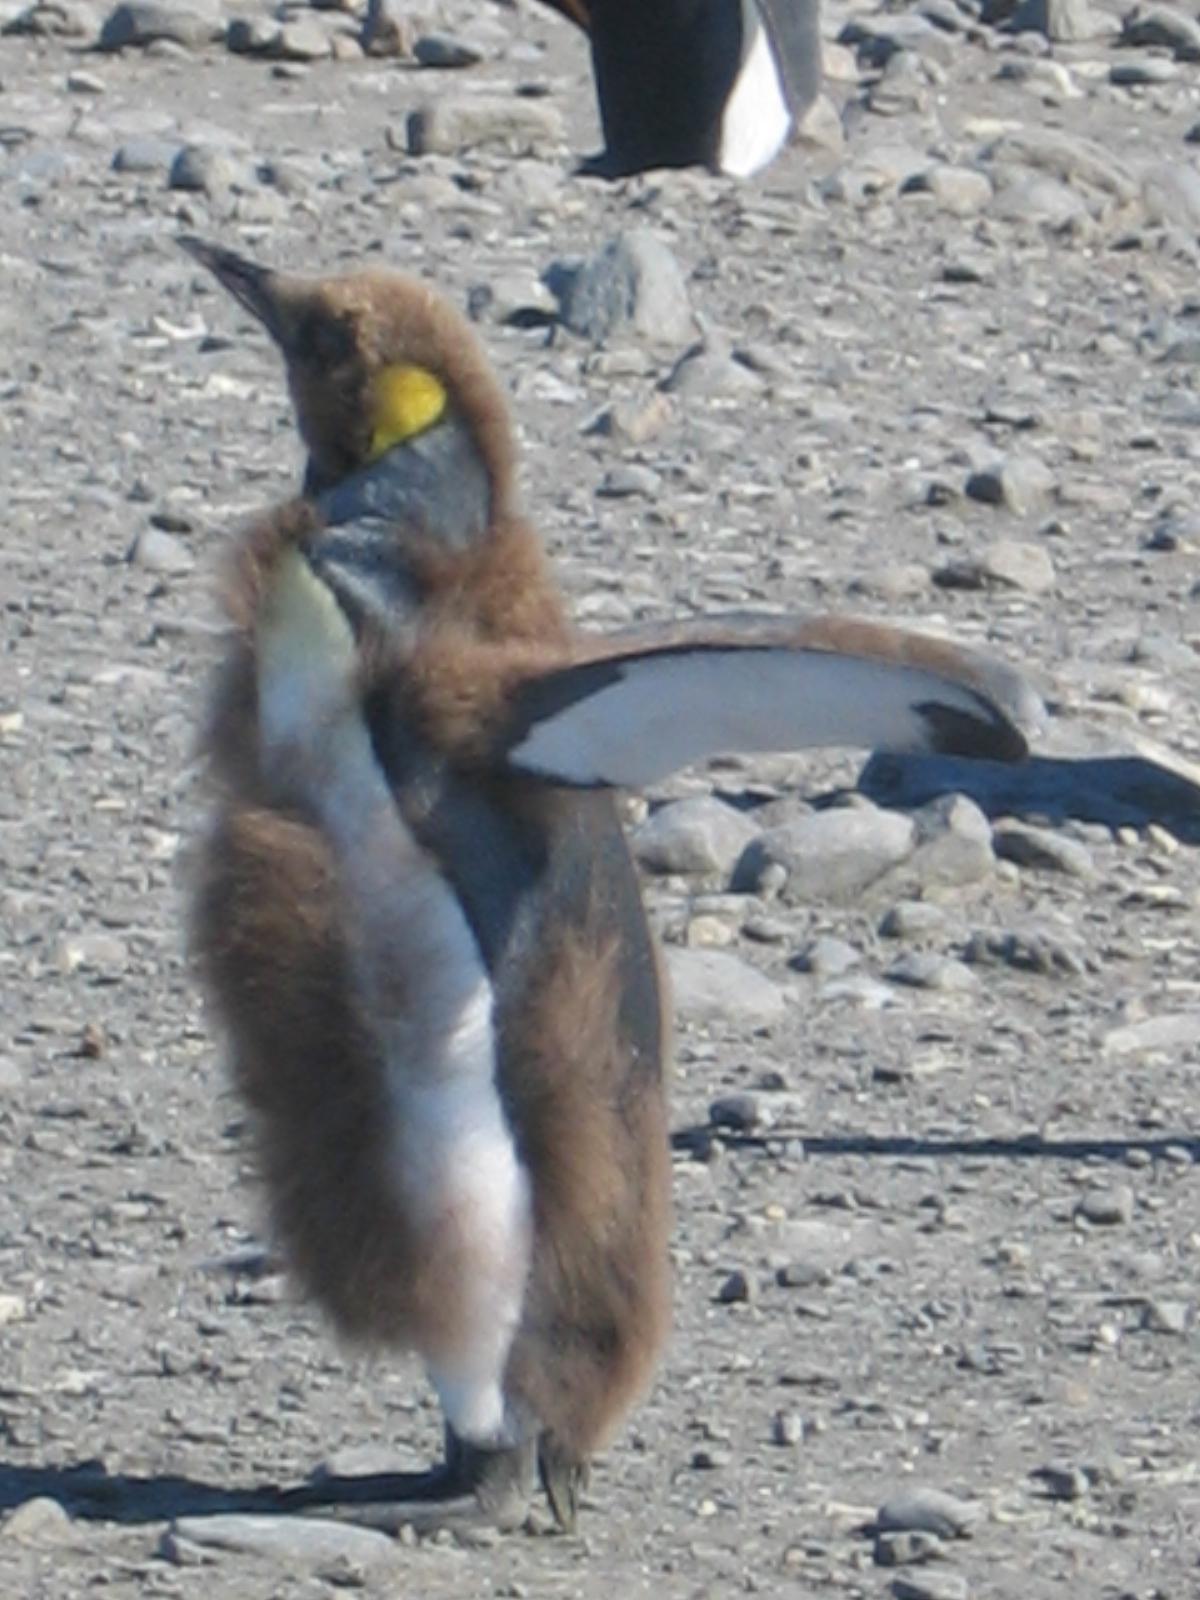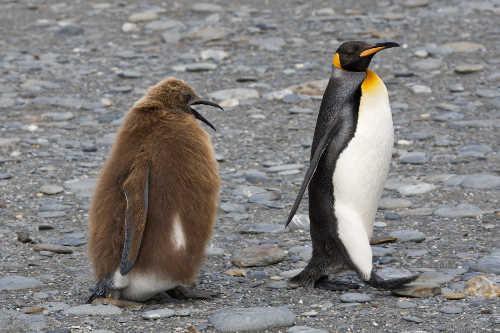The first image is the image on the left, the second image is the image on the right. Evaluate the accuracy of this statement regarding the images: "In one of the image a penguin is standing in snow.". Is it true? Answer yes or no. No. The first image is the image on the left, the second image is the image on the right. For the images shown, is this caption "One image has one penguin flexing its wings away from its body while its head is facing upwards." true? Answer yes or no. Yes. 